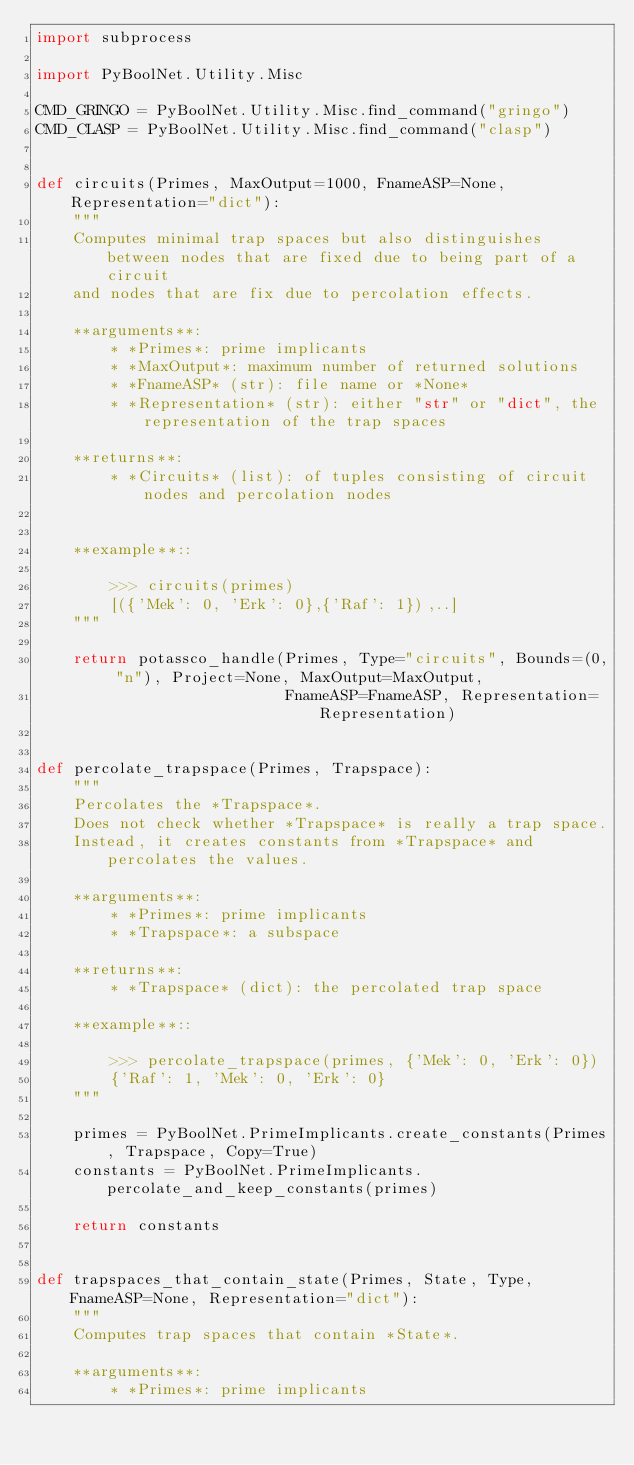Convert code to text. <code><loc_0><loc_0><loc_500><loc_500><_Python_>import subprocess

import PyBoolNet.Utility.Misc

CMD_GRINGO = PyBoolNet.Utility.Misc.find_command("gringo")
CMD_CLASP = PyBoolNet.Utility.Misc.find_command("clasp")


def circuits(Primes, MaxOutput=1000, FnameASP=None, Representation="dict"):
    """
    Computes minimal trap spaces but also distinguishes between nodes that are fixed due to being part of a circuit
    and nodes that are fix due to percolation effects.

    **arguments**:
        * *Primes*: prime implicants
        * *MaxOutput*: maximum number of returned solutions
        * *FnameASP* (str): file name or *None*
        * *Representation* (str): either "str" or "dict", the representation of the trap spaces

    **returns**:
        * *Circuits* (list): of tuples consisting of circuit nodes and percolation nodes


    **example**::

        >>> circuits(primes)
        [({'Mek': 0, 'Erk': 0},{'Raf': 1}),..]
    """
    
    return potassco_handle(Primes, Type="circuits", Bounds=(0, "n"), Project=None, MaxOutput=MaxOutput,
                           FnameASP=FnameASP, Representation=Representation)


def percolate_trapspace(Primes, Trapspace):
    """
    Percolates the *Trapspace*.
    Does not check whether *Trapspace* is really a trap space.
    Instead, it creates constants from *Trapspace* and percolates the values.

    **arguments**:
        * *Primes*: prime implicants
        * *Trapspace*: a subspace

    **returns**:
        * *Trapspace* (dict): the percolated trap space

    **example**::

        >>> percolate_trapspace(primes, {'Mek': 0, 'Erk': 0})
        {'Raf': 1, 'Mek': 0, 'Erk': 0}
    """
    
    primes = PyBoolNet.PrimeImplicants.create_constants(Primes, Trapspace, Copy=True)
    constants = PyBoolNet.PrimeImplicants.percolate_and_keep_constants(primes)
    
    return constants


def trapspaces_that_contain_state(Primes, State, Type, FnameASP=None, Representation="dict"):
    """
    Computes trap spaces that contain *State*.

    **arguments**:
        * *Primes*: prime implicants</code> 